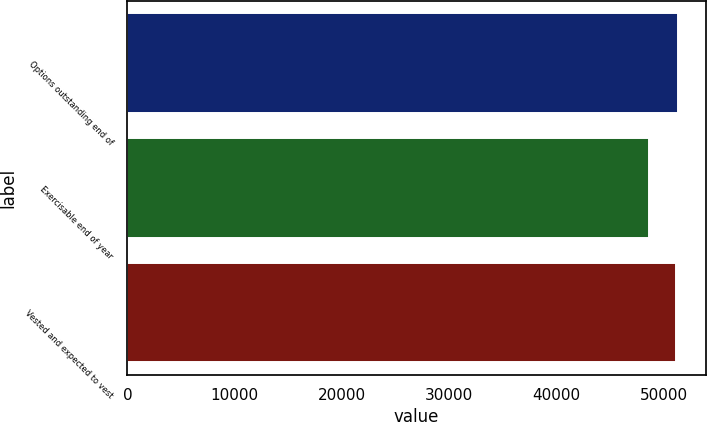Convert chart. <chart><loc_0><loc_0><loc_500><loc_500><bar_chart><fcel>Options outstanding end of<fcel>Exercisable end of year<fcel>Vested and expected to vest<nl><fcel>51329.2<fcel>48564<fcel>51071<nl></chart> 